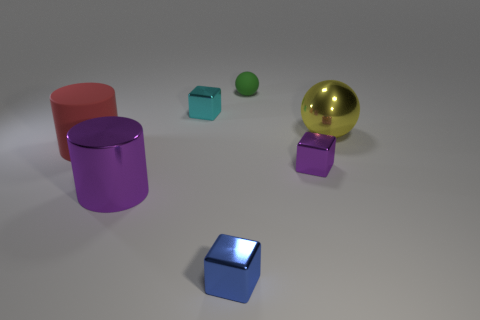Add 2 green metallic spheres. How many objects exist? 9 Subtract all cylinders. How many objects are left? 5 Add 6 small balls. How many small balls exist? 7 Subtract 0 gray cylinders. How many objects are left? 7 Subtract all large red rubber objects. Subtract all large purple cylinders. How many objects are left? 5 Add 7 big yellow shiny things. How many big yellow shiny things are left? 8 